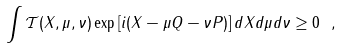Convert formula to latex. <formula><loc_0><loc_0><loc_500><loc_500>\int \mathcal { T } ( X , \mu , \nu ) \exp \left [ i ( X - \mu Q - \nu P ) \right ] d X d \mu d \nu \geq 0 \ ,</formula> 